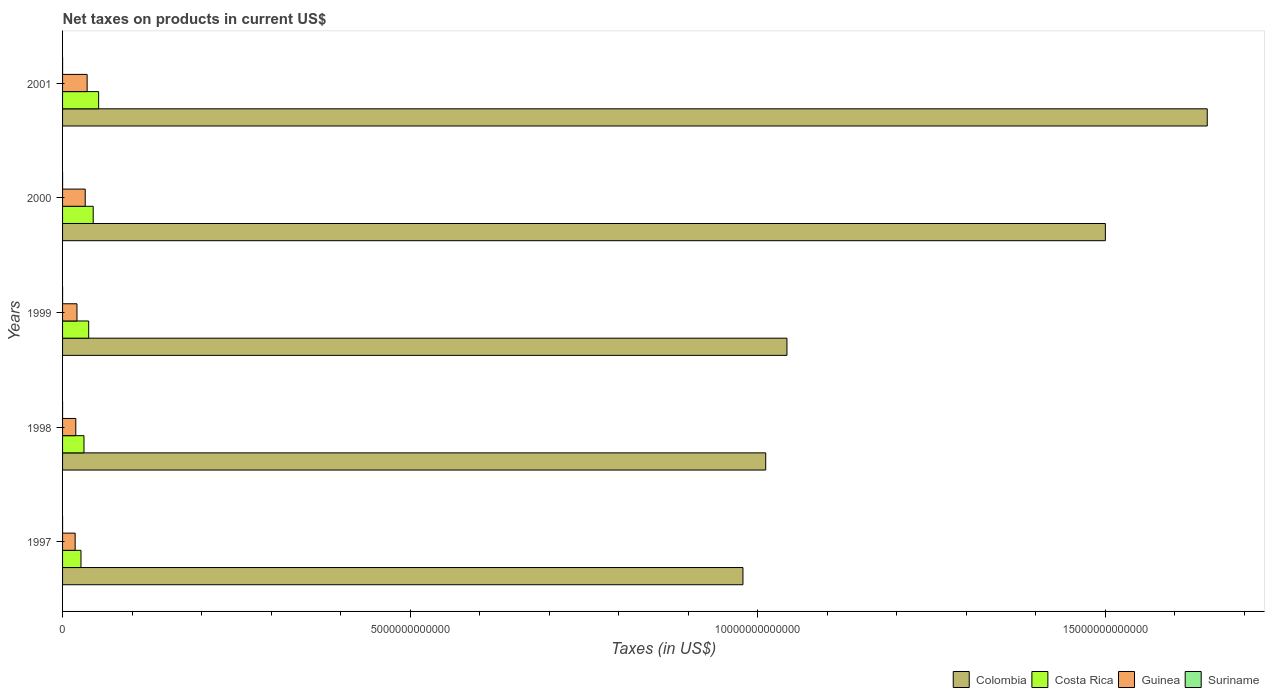Are the number of bars per tick equal to the number of legend labels?
Ensure brevity in your answer.  No. What is the net taxes on products in Colombia in 1998?
Offer a very short reply. 1.01e+13. Across all years, what is the maximum net taxes on products in Suriname?
Ensure brevity in your answer.  2.33e+08. Across all years, what is the minimum net taxes on products in Colombia?
Provide a short and direct response. 9.79e+12. In which year was the net taxes on products in Guinea maximum?
Offer a very short reply. 2001. What is the total net taxes on products in Suriname in the graph?
Your response must be concise. 4.60e+08. What is the difference between the net taxes on products in Costa Rica in 1998 and that in 2000?
Offer a terse response. -1.33e+11. What is the difference between the net taxes on products in Suriname in 2000 and the net taxes on products in Costa Rica in 1998?
Give a very brief answer. -3.08e+11. What is the average net taxes on products in Costa Rica per year?
Ensure brevity in your answer.  3.82e+11. In the year 1997, what is the difference between the net taxes on products in Costa Rica and net taxes on products in Colombia?
Offer a terse response. -9.52e+12. In how many years, is the net taxes on products in Guinea greater than 6000000000000 US$?
Ensure brevity in your answer.  0. What is the ratio of the net taxes on products in Guinea in 2000 to that in 2001?
Keep it short and to the point. 0.92. Is the net taxes on products in Guinea in 1998 less than that in 1999?
Provide a succinct answer. Yes. Is the difference between the net taxes on products in Costa Rica in 1999 and 2000 greater than the difference between the net taxes on products in Colombia in 1999 and 2000?
Your response must be concise. Yes. What is the difference between the highest and the second highest net taxes on products in Costa Rica?
Give a very brief answer. 7.80e+1. What is the difference between the highest and the lowest net taxes on products in Suriname?
Your answer should be compact. 2.33e+08. In how many years, is the net taxes on products in Costa Rica greater than the average net taxes on products in Costa Rica taken over all years?
Give a very brief answer. 2. Is it the case that in every year, the sum of the net taxes on products in Suriname and net taxes on products in Guinea is greater than the sum of net taxes on products in Costa Rica and net taxes on products in Colombia?
Offer a very short reply. No. Is it the case that in every year, the sum of the net taxes on products in Costa Rica and net taxes on products in Colombia is greater than the net taxes on products in Guinea?
Keep it short and to the point. Yes. Are all the bars in the graph horizontal?
Your answer should be very brief. Yes. How many years are there in the graph?
Provide a succinct answer. 5. What is the difference between two consecutive major ticks on the X-axis?
Your answer should be compact. 5.00e+12. Are the values on the major ticks of X-axis written in scientific E-notation?
Offer a terse response. No. Does the graph contain any zero values?
Give a very brief answer. Yes. Does the graph contain grids?
Provide a succinct answer. No. What is the title of the graph?
Offer a terse response. Net taxes on products in current US$. Does "Indonesia" appear as one of the legend labels in the graph?
Offer a very short reply. No. What is the label or title of the X-axis?
Make the answer very short. Taxes (in US$). What is the Taxes (in US$) of Colombia in 1997?
Keep it short and to the point. 9.79e+12. What is the Taxes (in US$) of Costa Rica in 1997?
Your response must be concise. 2.65e+11. What is the Taxes (in US$) in Guinea in 1997?
Give a very brief answer. 1.81e+11. What is the Taxes (in US$) of Suriname in 1997?
Give a very brief answer. 2.58e+07. What is the Taxes (in US$) of Colombia in 1998?
Provide a succinct answer. 1.01e+13. What is the Taxes (in US$) of Costa Rica in 1998?
Provide a succinct answer. 3.08e+11. What is the Taxes (in US$) in Guinea in 1998?
Ensure brevity in your answer.  1.90e+11. What is the Taxes (in US$) of Colombia in 1999?
Make the answer very short. 1.04e+13. What is the Taxes (in US$) in Costa Rica in 1999?
Your answer should be compact. 3.76e+11. What is the Taxes (in US$) in Guinea in 1999?
Offer a very short reply. 2.07e+11. What is the Taxes (in US$) in Suriname in 1999?
Provide a short and direct response. 9.51e+07. What is the Taxes (in US$) in Colombia in 2000?
Make the answer very short. 1.50e+13. What is the Taxes (in US$) in Costa Rica in 2000?
Your answer should be very brief. 4.41e+11. What is the Taxes (in US$) of Guinea in 2000?
Make the answer very short. 3.26e+11. What is the Taxes (in US$) in Suriname in 2000?
Your answer should be compact. 1.06e+08. What is the Taxes (in US$) in Colombia in 2001?
Your response must be concise. 1.65e+13. What is the Taxes (in US$) of Costa Rica in 2001?
Make the answer very short. 5.19e+11. What is the Taxes (in US$) of Guinea in 2001?
Offer a very short reply. 3.53e+11. What is the Taxes (in US$) of Suriname in 2001?
Make the answer very short. 2.33e+08. Across all years, what is the maximum Taxes (in US$) of Colombia?
Give a very brief answer. 1.65e+13. Across all years, what is the maximum Taxes (in US$) of Costa Rica?
Your answer should be compact. 5.19e+11. Across all years, what is the maximum Taxes (in US$) of Guinea?
Your answer should be very brief. 3.53e+11. Across all years, what is the maximum Taxes (in US$) of Suriname?
Ensure brevity in your answer.  2.33e+08. Across all years, what is the minimum Taxes (in US$) of Colombia?
Keep it short and to the point. 9.79e+12. Across all years, what is the minimum Taxes (in US$) in Costa Rica?
Your answer should be very brief. 2.65e+11. Across all years, what is the minimum Taxes (in US$) of Guinea?
Provide a succinct answer. 1.81e+11. What is the total Taxes (in US$) of Colombia in the graph?
Give a very brief answer. 6.18e+13. What is the total Taxes (in US$) in Costa Rica in the graph?
Your response must be concise. 1.91e+12. What is the total Taxes (in US$) in Guinea in the graph?
Ensure brevity in your answer.  1.26e+12. What is the total Taxes (in US$) of Suriname in the graph?
Keep it short and to the point. 4.60e+08. What is the difference between the Taxes (in US$) in Colombia in 1997 and that in 1998?
Your answer should be very brief. -3.27e+11. What is the difference between the Taxes (in US$) of Costa Rica in 1997 and that in 1998?
Your answer should be very brief. -4.32e+1. What is the difference between the Taxes (in US$) of Guinea in 1997 and that in 1998?
Your response must be concise. -9.19e+09. What is the difference between the Taxes (in US$) in Colombia in 1997 and that in 1999?
Your answer should be compact. -6.33e+11. What is the difference between the Taxes (in US$) of Costa Rica in 1997 and that in 1999?
Offer a terse response. -1.11e+11. What is the difference between the Taxes (in US$) of Guinea in 1997 and that in 1999?
Ensure brevity in your answer.  -2.62e+1. What is the difference between the Taxes (in US$) in Suriname in 1997 and that in 1999?
Provide a succinct answer. -6.93e+07. What is the difference between the Taxes (in US$) of Colombia in 1997 and that in 2000?
Your response must be concise. -5.21e+12. What is the difference between the Taxes (in US$) in Costa Rica in 1997 and that in 2000?
Your answer should be very brief. -1.76e+11. What is the difference between the Taxes (in US$) in Guinea in 1997 and that in 2000?
Give a very brief answer. -1.45e+11. What is the difference between the Taxes (in US$) of Suriname in 1997 and that in 2000?
Keep it short and to the point. -7.99e+07. What is the difference between the Taxes (in US$) of Colombia in 1997 and that in 2001?
Make the answer very short. -6.68e+12. What is the difference between the Taxes (in US$) of Costa Rica in 1997 and that in 2001?
Offer a terse response. -2.54e+11. What is the difference between the Taxes (in US$) of Guinea in 1997 and that in 2001?
Your answer should be very brief. -1.72e+11. What is the difference between the Taxes (in US$) of Suriname in 1997 and that in 2001?
Offer a terse response. -2.07e+08. What is the difference between the Taxes (in US$) of Colombia in 1998 and that in 1999?
Keep it short and to the point. -3.05e+11. What is the difference between the Taxes (in US$) in Costa Rica in 1998 and that in 1999?
Give a very brief answer. -6.76e+1. What is the difference between the Taxes (in US$) in Guinea in 1998 and that in 1999?
Your response must be concise. -1.70e+1. What is the difference between the Taxes (in US$) of Colombia in 1998 and that in 2000?
Provide a succinct answer. -4.89e+12. What is the difference between the Taxes (in US$) in Costa Rica in 1998 and that in 2000?
Ensure brevity in your answer.  -1.33e+11. What is the difference between the Taxes (in US$) of Guinea in 1998 and that in 2000?
Your answer should be very brief. -1.36e+11. What is the difference between the Taxes (in US$) in Colombia in 1998 and that in 2001?
Provide a succinct answer. -6.35e+12. What is the difference between the Taxes (in US$) in Costa Rica in 1998 and that in 2001?
Offer a terse response. -2.11e+11. What is the difference between the Taxes (in US$) in Guinea in 1998 and that in 2001?
Give a very brief answer. -1.63e+11. What is the difference between the Taxes (in US$) of Colombia in 1999 and that in 2000?
Your response must be concise. -4.58e+12. What is the difference between the Taxes (in US$) of Costa Rica in 1999 and that in 2000?
Provide a succinct answer. -6.51e+1. What is the difference between the Taxes (in US$) in Guinea in 1999 and that in 2000?
Offer a terse response. -1.19e+11. What is the difference between the Taxes (in US$) in Suriname in 1999 and that in 2000?
Ensure brevity in your answer.  -1.06e+07. What is the difference between the Taxes (in US$) of Colombia in 1999 and that in 2001?
Provide a succinct answer. -6.05e+12. What is the difference between the Taxes (in US$) in Costa Rica in 1999 and that in 2001?
Make the answer very short. -1.43e+11. What is the difference between the Taxes (in US$) in Guinea in 1999 and that in 2001?
Offer a very short reply. -1.46e+11. What is the difference between the Taxes (in US$) of Suriname in 1999 and that in 2001?
Give a very brief answer. -1.38e+08. What is the difference between the Taxes (in US$) in Colombia in 2000 and that in 2001?
Offer a very short reply. -1.47e+12. What is the difference between the Taxes (in US$) in Costa Rica in 2000 and that in 2001?
Your answer should be very brief. -7.80e+1. What is the difference between the Taxes (in US$) in Guinea in 2000 and that in 2001?
Make the answer very short. -2.76e+1. What is the difference between the Taxes (in US$) of Suriname in 2000 and that in 2001?
Your answer should be compact. -1.27e+08. What is the difference between the Taxes (in US$) in Colombia in 1997 and the Taxes (in US$) in Costa Rica in 1998?
Offer a very short reply. 9.48e+12. What is the difference between the Taxes (in US$) in Colombia in 1997 and the Taxes (in US$) in Guinea in 1998?
Provide a succinct answer. 9.60e+12. What is the difference between the Taxes (in US$) of Costa Rica in 1997 and the Taxes (in US$) of Guinea in 1998?
Keep it short and to the point. 7.46e+1. What is the difference between the Taxes (in US$) in Colombia in 1997 and the Taxes (in US$) in Costa Rica in 1999?
Offer a terse response. 9.41e+12. What is the difference between the Taxes (in US$) in Colombia in 1997 and the Taxes (in US$) in Guinea in 1999?
Your answer should be very brief. 9.58e+12. What is the difference between the Taxes (in US$) of Colombia in 1997 and the Taxes (in US$) of Suriname in 1999?
Your answer should be very brief. 9.79e+12. What is the difference between the Taxes (in US$) in Costa Rica in 1997 and the Taxes (in US$) in Guinea in 1999?
Make the answer very short. 5.76e+1. What is the difference between the Taxes (in US$) in Costa Rica in 1997 and the Taxes (in US$) in Suriname in 1999?
Make the answer very short. 2.65e+11. What is the difference between the Taxes (in US$) in Guinea in 1997 and the Taxes (in US$) in Suriname in 1999?
Ensure brevity in your answer.  1.81e+11. What is the difference between the Taxes (in US$) of Colombia in 1997 and the Taxes (in US$) of Costa Rica in 2000?
Offer a very short reply. 9.35e+12. What is the difference between the Taxes (in US$) of Colombia in 1997 and the Taxes (in US$) of Guinea in 2000?
Offer a terse response. 9.46e+12. What is the difference between the Taxes (in US$) in Colombia in 1997 and the Taxes (in US$) in Suriname in 2000?
Your answer should be very brief. 9.79e+12. What is the difference between the Taxes (in US$) of Costa Rica in 1997 and the Taxes (in US$) of Guinea in 2000?
Your answer should be compact. -6.10e+1. What is the difference between the Taxes (in US$) in Costa Rica in 1997 and the Taxes (in US$) in Suriname in 2000?
Offer a terse response. 2.65e+11. What is the difference between the Taxes (in US$) of Guinea in 1997 and the Taxes (in US$) of Suriname in 2000?
Offer a very short reply. 1.81e+11. What is the difference between the Taxes (in US$) of Colombia in 1997 and the Taxes (in US$) of Costa Rica in 2001?
Your response must be concise. 9.27e+12. What is the difference between the Taxes (in US$) in Colombia in 1997 and the Taxes (in US$) in Guinea in 2001?
Provide a short and direct response. 9.43e+12. What is the difference between the Taxes (in US$) in Colombia in 1997 and the Taxes (in US$) in Suriname in 2001?
Offer a very short reply. 9.79e+12. What is the difference between the Taxes (in US$) of Costa Rica in 1997 and the Taxes (in US$) of Guinea in 2001?
Your answer should be very brief. -8.86e+1. What is the difference between the Taxes (in US$) of Costa Rica in 1997 and the Taxes (in US$) of Suriname in 2001?
Make the answer very short. 2.65e+11. What is the difference between the Taxes (in US$) of Guinea in 1997 and the Taxes (in US$) of Suriname in 2001?
Keep it short and to the point. 1.81e+11. What is the difference between the Taxes (in US$) of Colombia in 1998 and the Taxes (in US$) of Costa Rica in 1999?
Make the answer very short. 9.74e+12. What is the difference between the Taxes (in US$) of Colombia in 1998 and the Taxes (in US$) of Guinea in 1999?
Keep it short and to the point. 9.91e+12. What is the difference between the Taxes (in US$) in Colombia in 1998 and the Taxes (in US$) in Suriname in 1999?
Offer a very short reply. 1.01e+13. What is the difference between the Taxes (in US$) in Costa Rica in 1998 and the Taxes (in US$) in Guinea in 1999?
Provide a short and direct response. 1.01e+11. What is the difference between the Taxes (in US$) of Costa Rica in 1998 and the Taxes (in US$) of Suriname in 1999?
Offer a very short reply. 3.08e+11. What is the difference between the Taxes (in US$) of Guinea in 1998 and the Taxes (in US$) of Suriname in 1999?
Offer a terse response. 1.90e+11. What is the difference between the Taxes (in US$) in Colombia in 1998 and the Taxes (in US$) in Costa Rica in 2000?
Offer a very short reply. 9.67e+12. What is the difference between the Taxes (in US$) of Colombia in 1998 and the Taxes (in US$) of Guinea in 2000?
Make the answer very short. 9.79e+12. What is the difference between the Taxes (in US$) in Colombia in 1998 and the Taxes (in US$) in Suriname in 2000?
Provide a succinct answer. 1.01e+13. What is the difference between the Taxes (in US$) in Costa Rica in 1998 and the Taxes (in US$) in Guinea in 2000?
Your answer should be very brief. -1.78e+1. What is the difference between the Taxes (in US$) in Costa Rica in 1998 and the Taxes (in US$) in Suriname in 2000?
Offer a terse response. 3.08e+11. What is the difference between the Taxes (in US$) in Guinea in 1998 and the Taxes (in US$) in Suriname in 2000?
Provide a succinct answer. 1.90e+11. What is the difference between the Taxes (in US$) in Colombia in 1998 and the Taxes (in US$) in Costa Rica in 2001?
Your answer should be compact. 9.60e+12. What is the difference between the Taxes (in US$) of Colombia in 1998 and the Taxes (in US$) of Guinea in 2001?
Ensure brevity in your answer.  9.76e+12. What is the difference between the Taxes (in US$) of Colombia in 1998 and the Taxes (in US$) of Suriname in 2001?
Provide a succinct answer. 1.01e+13. What is the difference between the Taxes (in US$) in Costa Rica in 1998 and the Taxes (in US$) in Guinea in 2001?
Your answer should be very brief. -4.53e+1. What is the difference between the Taxes (in US$) in Costa Rica in 1998 and the Taxes (in US$) in Suriname in 2001?
Your answer should be very brief. 3.08e+11. What is the difference between the Taxes (in US$) of Guinea in 1998 and the Taxes (in US$) of Suriname in 2001?
Provide a succinct answer. 1.90e+11. What is the difference between the Taxes (in US$) in Colombia in 1999 and the Taxes (in US$) in Costa Rica in 2000?
Give a very brief answer. 9.98e+12. What is the difference between the Taxes (in US$) in Colombia in 1999 and the Taxes (in US$) in Guinea in 2000?
Your answer should be very brief. 1.01e+13. What is the difference between the Taxes (in US$) in Colombia in 1999 and the Taxes (in US$) in Suriname in 2000?
Ensure brevity in your answer.  1.04e+13. What is the difference between the Taxes (in US$) of Costa Rica in 1999 and the Taxes (in US$) of Guinea in 2000?
Offer a terse response. 4.98e+1. What is the difference between the Taxes (in US$) of Costa Rica in 1999 and the Taxes (in US$) of Suriname in 2000?
Provide a succinct answer. 3.76e+11. What is the difference between the Taxes (in US$) in Guinea in 1999 and the Taxes (in US$) in Suriname in 2000?
Give a very brief answer. 2.07e+11. What is the difference between the Taxes (in US$) in Colombia in 1999 and the Taxes (in US$) in Costa Rica in 2001?
Your response must be concise. 9.90e+12. What is the difference between the Taxes (in US$) in Colombia in 1999 and the Taxes (in US$) in Guinea in 2001?
Ensure brevity in your answer.  1.01e+13. What is the difference between the Taxes (in US$) of Colombia in 1999 and the Taxes (in US$) of Suriname in 2001?
Make the answer very short. 1.04e+13. What is the difference between the Taxes (in US$) in Costa Rica in 1999 and the Taxes (in US$) in Guinea in 2001?
Your response must be concise. 2.23e+1. What is the difference between the Taxes (in US$) in Costa Rica in 1999 and the Taxes (in US$) in Suriname in 2001?
Your response must be concise. 3.75e+11. What is the difference between the Taxes (in US$) in Guinea in 1999 and the Taxes (in US$) in Suriname in 2001?
Provide a succinct answer. 2.07e+11. What is the difference between the Taxes (in US$) in Colombia in 2000 and the Taxes (in US$) in Costa Rica in 2001?
Give a very brief answer. 1.45e+13. What is the difference between the Taxes (in US$) in Colombia in 2000 and the Taxes (in US$) in Guinea in 2001?
Keep it short and to the point. 1.46e+13. What is the difference between the Taxes (in US$) in Colombia in 2000 and the Taxes (in US$) in Suriname in 2001?
Offer a terse response. 1.50e+13. What is the difference between the Taxes (in US$) in Costa Rica in 2000 and the Taxes (in US$) in Guinea in 2001?
Give a very brief answer. 8.74e+1. What is the difference between the Taxes (in US$) of Costa Rica in 2000 and the Taxes (in US$) of Suriname in 2001?
Your answer should be very brief. 4.41e+11. What is the difference between the Taxes (in US$) in Guinea in 2000 and the Taxes (in US$) in Suriname in 2001?
Your answer should be very brief. 3.26e+11. What is the average Taxes (in US$) of Colombia per year?
Make the answer very short. 1.24e+13. What is the average Taxes (in US$) of Costa Rica per year?
Make the answer very short. 3.82e+11. What is the average Taxes (in US$) of Guinea per year?
Your answer should be very brief. 2.52e+11. What is the average Taxes (in US$) of Suriname per year?
Keep it short and to the point. 9.19e+07. In the year 1997, what is the difference between the Taxes (in US$) in Colombia and Taxes (in US$) in Costa Rica?
Keep it short and to the point. 9.52e+12. In the year 1997, what is the difference between the Taxes (in US$) in Colombia and Taxes (in US$) in Guinea?
Keep it short and to the point. 9.61e+12. In the year 1997, what is the difference between the Taxes (in US$) of Colombia and Taxes (in US$) of Suriname?
Give a very brief answer. 9.79e+12. In the year 1997, what is the difference between the Taxes (in US$) in Costa Rica and Taxes (in US$) in Guinea?
Your response must be concise. 8.38e+1. In the year 1997, what is the difference between the Taxes (in US$) in Costa Rica and Taxes (in US$) in Suriname?
Provide a succinct answer. 2.65e+11. In the year 1997, what is the difference between the Taxes (in US$) in Guinea and Taxes (in US$) in Suriname?
Provide a short and direct response. 1.81e+11. In the year 1998, what is the difference between the Taxes (in US$) in Colombia and Taxes (in US$) in Costa Rica?
Your answer should be compact. 9.81e+12. In the year 1998, what is the difference between the Taxes (in US$) in Colombia and Taxes (in US$) in Guinea?
Offer a terse response. 9.93e+12. In the year 1998, what is the difference between the Taxes (in US$) of Costa Rica and Taxes (in US$) of Guinea?
Provide a succinct answer. 1.18e+11. In the year 1999, what is the difference between the Taxes (in US$) of Colombia and Taxes (in US$) of Costa Rica?
Offer a very short reply. 1.00e+13. In the year 1999, what is the difference between the Taxes (in US$) of Colombia and Taxes (in US$) of Guinea?
Keep it short and to the point. 1.02e+13. In the year 1999, what is the difference between the Taxes (in US$) in Colombia and Taxes (in US$) in Suriname?
Your response must be concise. 1.04e+13. In the year 1999, what is the difference between the Taxes (in US$) in Costa Rica and Taxes (in US$) in Guinea?
Your answer should be very brief. 1.68e+11. In the year 1999, what is the difference between the Taxes (in US$) in Costa Rica and Taxes (in US$) in Suriname?
Give a very brief answer. 3.76e+11. In the year 1999, what is the difference between the Taxes (in US$) of Guinea and Taxes (in US$) of Suriname?
Offer a terse response. 2.07e+11. In the year 2000, what is the difference between the Taxes (in US$) in Colombia and Taxes (in US$) in Costa Rica?
Make the answer very short. 1.46e+13. In the year 2000, what is the difference between the Taxes (in US$) of Colombia and Taxes (in US$) of Guinea?
Provide a short and direct response. 1.47e+13. In the year 2000, what is the difference between the Taxes (in US$) of Colombia and Taxes (in US$) of Suriname?
Make the answer very short. 1.50e+13. In the year 2000, what is the difference between the Taxes (in US$) of Costa Rica and Taxes (in US$) of Guinea?
Your response must be concise. 1.15e+11. In the year 2000, what is the difference between the Taxes (in US$) in Costa Rica and Taxes (in US$) in Suriname?
Your response must be concise. 4.41e+11. In the year 2000, what is the difference between the Taxes (in US$) of Guinea and Taxes (in US$) of Suriname?
Your answer should be very brief. 3.26e+11. In the year 2001, what is the difference between the Taxes (in US$) in Colombia and Taxes (in US$) in Costa Rica?
Give a very brief answer. 1.59e+13. In the year 2001, what is the difference between the Taxes (in US$) of Colombia and Taxes (in US$) of Guinea?
Provide a short and direct response. 1.61e+13. In the year 2001, what is the difference between the Taxes (in US$) in Colombia and Taxes (in US$) in Suriname?
Your response must be concise. 1.65e+13. In the year 2001, what is the difference between the Taxes (in US$) of Costa Rica and Taxes (in US$) of Guinea?
Give a very brief answer. 1.65e+11. In the year 2001, what is the difference between the Taxes (in US$) in Costa Rica and Taxes (in US$) in Suriname?
Give a very brief answer. 5.19e+11. In the year 2001, what is the difference between the Taxes (in US$) in Guinea and Taxes (in US$) in Suriname?
Provide a short and direct response. 3.53e+11. What is the ratio of the Taxes (in US$) of Colombia in 1997 to that in 1998?
Offer a very short reply. 0.97. What is the ratio of the Taxes (in US$) in Costa Rica in 1997 to that in 1998?
Your answer should be compact. 0.86. What is the ratio of the Taxes (in US$) of Guinea in 1997 to that in 1998?
Offer a very short reply. 0.95. What is the ratio of the Taxes (in US$) of Colombia in 1997 to that in 1999?
Provide a short and direct response. 0.94. What is the ratio of the Taxes (in US$) of Costa Rica in 1997 to that in 1999?
Your answer should be very brief. 0.7. What is the ratio of the Taxes (in US$) of Guinea in 1997 to that in 1999?
Make the answer very short. 0.87. What is the ratio of the Taxes (in US$) of Suriname in 1997 to that in 1999?
Offer a terse response. 0.27. What is the ratio of the Taxes (in US$) in Colombia in 1997 to that in 2000?
Make the answer very short. 0.65. What is the ratio of the Taxes (in US$) in Costa Rica in 1997 to that in 2000?
Your answer should be compact. 0.6. What is the ratio of the Taxes (in US$) of Guinea in 1997 to that in 2000?
Your answer should be compact. 0.56. What is the ratio of the Taxes (in US$) in Suriname in 1997 to that in 2000?
Keep it short and to the point. 0.24. What is the ratio of the Taxes (in US$) of Colombia in 1997 to that in 2001?
Your response must be concise. 0.59. What is the ratio of the Taxes (in US$) of Costa Rica in 1997 to that in 2001?
Offer a terse response. 0.51. What is the ratio of the Taxes (in US$) in Guinea in 1997 to that in 2001?
Offer a very short reply. 0.51. What is the ratio of the Taxes (in US$) of Suriname in 1997 to that in 2001?
Offer a terse response. 0.11. What is the ratio of the Taxes (in US$) in Colombia in 1998 to that in 1999?
Provide a short and direct response. 0.97. What is the ratio of the Taxes (in US$) of Costa Rica in 1998 to that in 1999?
Offer a terse response. 0.82. What is the ratio of the Taxes (in US$) of Guinea in 1998 to that in 1999?
Offer a terse response. 0.92. What is the ratio of the Taxes (in US$) of Colombia in 1998 to that in 2000?
Ensure brevity in your answer.  0.67. What is the ratio of the Taxes (in US$) of Costa Rica in 1998 to that in 2000?
Make the answer very short. 0.7. What is the ratio of the Taxes (in US$) of Guinea in 1998 to that in 2000?
Your response must be concise. 0.58. What is the ratio of the Taxes (in US$) in Colombia in 1998 to that in 2001?
Your answer should be compact. 0.61. What is the ratio of the Taxes (in US$) of Costa Rica in 1998 to that in 2001?
Offer a terse response. 0.59. What is the ratio of the Taxes (in US$) in Guinea in 1998 to that in 2001?
Give a very brief answer. 0.54. What is the ratio of the Taxes (in US$) in Colombia in 1999 to that in 2000?
Your answer should be very brief. 0.69. What is the ratio of the Taxes (in US$) in Costa Rica in 1999 to that in 2000?
Your answer should be very brief. 0.85. What is the ratio of the Taxes (in US$) in Guinea in 1999 to that in 2000?
Your response must be concise. 0.64. What is the ratio of the Taxes (in US$) in Suriname in 1999 to that in 2000?
Provide a succinct answer. 0.9. What is the ratio of the Taxes (in US$) of Colombia in 1999 to that in 2001?
Give a very brief answer. 0.63. What is the ratio of the Taxes (in US$) of Costa Rica in 1999 to that in 2001?
Provide a succinct answer. 0.72. What is the ratio of the Taxes (in US$) of Guinea in 1999 to that in 2001?
Give a very brief answer. 0.59. What is the ratio of the Taxes (in US$) of Suriname in 1999 to that in 2001?
Provide a short and direct response. 0.41. What is the ratio of the Taxes (in US$) in Colombia in 2000 to that in 2001?
Offer a very short reply. 0.91. What is the ratio of the Taxes (in US$) in Costa Rica in 2000 to that in 2001?
Your response must be concise. 0.85. What is the ratio of the Taxes (in US$) of Guinea in 2000 to that in 2001?
Your response must be concise. 0.92. What is the ratio of the Taxes (in US$) in Suriname in 2000 to that in 2001?
Your response must be concise. 0.45. What is the difference between the highest and the second highest Taxes (in US$) of Colombia?
Provide a succinct answer. 1.47e+12. What is the difference between the highest and the second highest Taxes (in US$) of Costa Rica?
Your answer should be very brief. 7.80e+1. What is the difference between the highest and the second highest Taxes (in US$) in Guinea?
Provide a succinct answer. 2.76e+1. What is the difference between the highest and the second highest Taxes (in US$) in Suriname?
Make the answer very short. 1.27e+08. What is the difference between the highest and the lowest Taxes (in US$) in Colombia?
Offer a terse response. 6.68e+12. What is the difference between the highest and the lowest Taxes (in US$) in Costa Rica?
Provide a short and direct response. 2.54e+11. What is the difference between the highest and the lowest Taxes (in US$) in Guinea?
Offer a very short reply. 1.72e+11. What is the difference between the highest and the lowest Taxes (in US$) in Suriname?
Provide a short and direct response. 2.33e+08. 